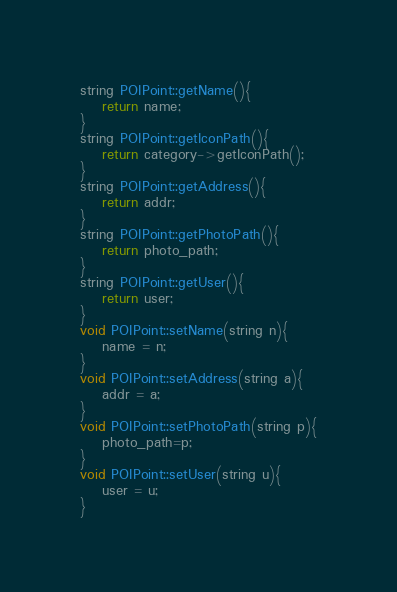<code> <loc_0><loc_0><loc_500><loc_500><_C++_>string POIPoint::getName(){
    return name;
}
string POIPoint::getIconPath(){
    return category->getIconPath();
}
string POIPoint::getAddress(){
    return addr;
}
string POIPoint::getPhotoPath(){
    return photo_path;
}
string POIPoint::getUser(){
    return user;
}
void POIPoint::setName(string n){
    name = n;
}
void POIPoint::setAddress(string a){
    addr = a;
}
void POIPoint::setPhotoPath(string p){
    photo_path=p;
}
void POIPoint::setUser(string u){
    user = u;
}
</code> 